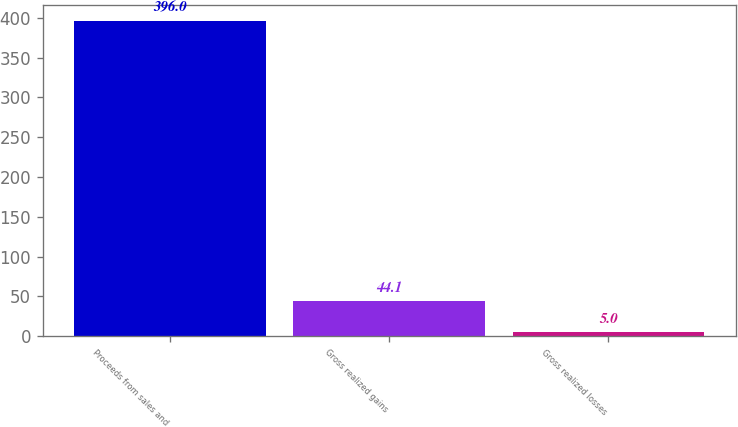Convert chart. <chart><loc_0><loc_0><loc_500><loc_500><bar_chart><fcel>Proceeds from sales and<fcel>Gross realized gains<fcel>Gross realized losses<nl><fcel>396<fcel>44.1<fcel>5<nl></chart> 